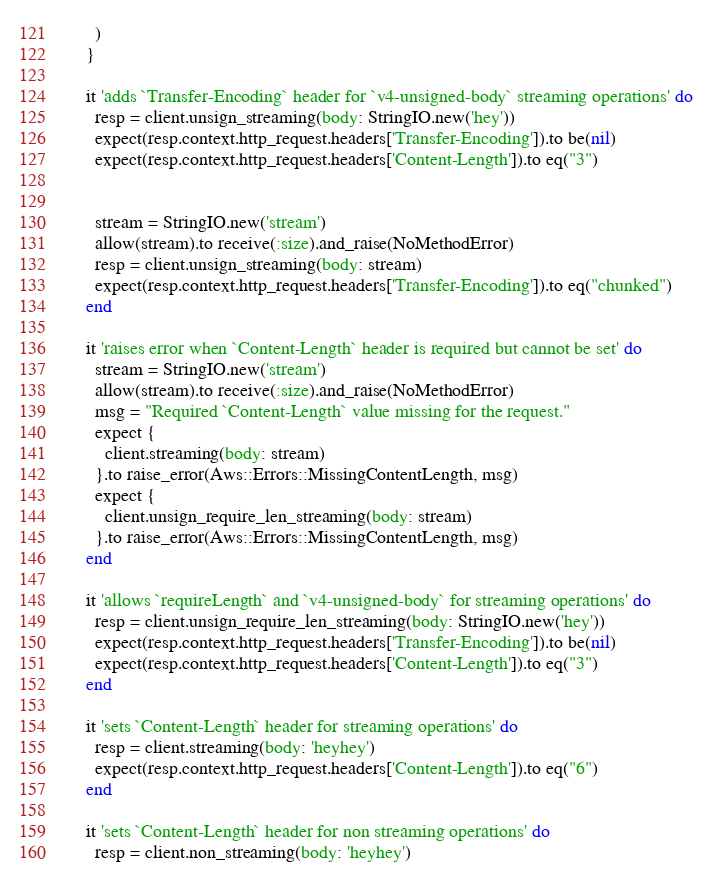Convert code to text. <code><loc_0><loc_0><loc_500><loc_500><_Ruby_>      )
    }

    it 'adds `Transfer-Encoding` header for `v4-unsigned-body` streaming operations' do
      resp = client.unsign_streaming(body: StringIO.new('hey'))
      expect(resp.context.http_request.headers['Transfer-Encoding']).to be(nil)
      expect(resp.context.http_request.headers['Content-Length']).to eq("3")


      stream = StringIO.new('stream')
      allow(stream).to receive(:size).and_raise(NoMethodError)
      resp = client.unsign_streaming(body: stream)
      expect(resp.context.http_request.headers['Transfer-Encoding']).to eq("chunked")
    end

    it 'raises error when `Content-Length` header is required but cannot be set' do
      stream = StringIO.new('stream')
      allow(stream).to receive(:size).and_raise(NoMethodError)
      msg = "Required `Content-Length` value missing for the request."
      expect {
        client.streaming(body: stream)
      }.to raise_error(Aws::Errors::MissingContentLength, msg)
      expect {
        client.unsign_require_len_streaming(body: stream)
      }.to raise_error(Aws::Errors::MissingContentLength, msg)
    end

    it 'allows `requireLength` and `v4-unsigned-body` for streaming operations' do
      resp = client.unsign_require_len_streaming(body: StringIO.new('hey'))
      expect(resp.context.http_request.headers['Transfer-Encoding']).to be(nil)
      expect(resp.context.http_request.headers['Content-Length']).to eq("3")
    end

    it 'sets `Content-Length` header for streaming operations' do
      resp = client.streaming(body: 'heyhey')
      expect(resp.context.http_request.headers['Content-Length']).to eq("6")
    end

    it 'sets `Content-Length` header for non streaming operations' do
      resp = client.non_streaming(body: 'heyhey')</code> 